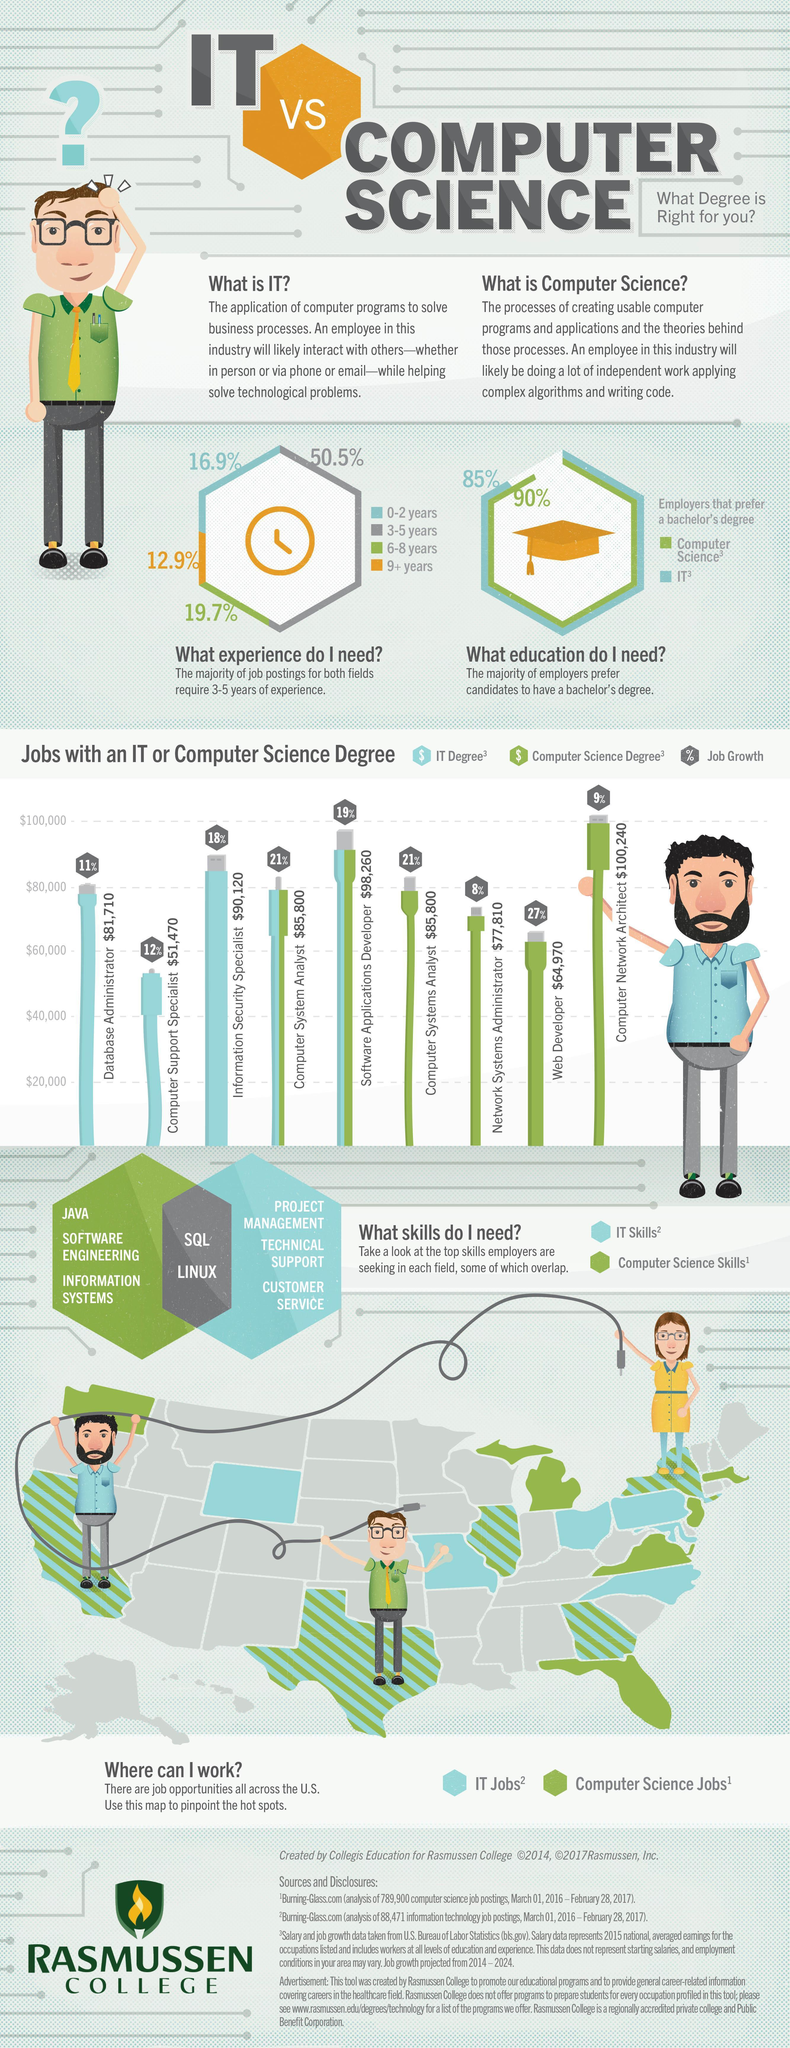What is the percentage of job growth for web developers and computer system analysts, taken together?
Answer the question with a short phrase. 48% Which has the highest share-6-8years,3-5years? 3-5years What is the percentage of employers that prefer a bachelor's degree in Computer science? 90% What is the percentage of employers that prefer a bachelor's degree in IT? 85% What is the percentage of job growth for database administrators and computer network architects, taken together? 20% 